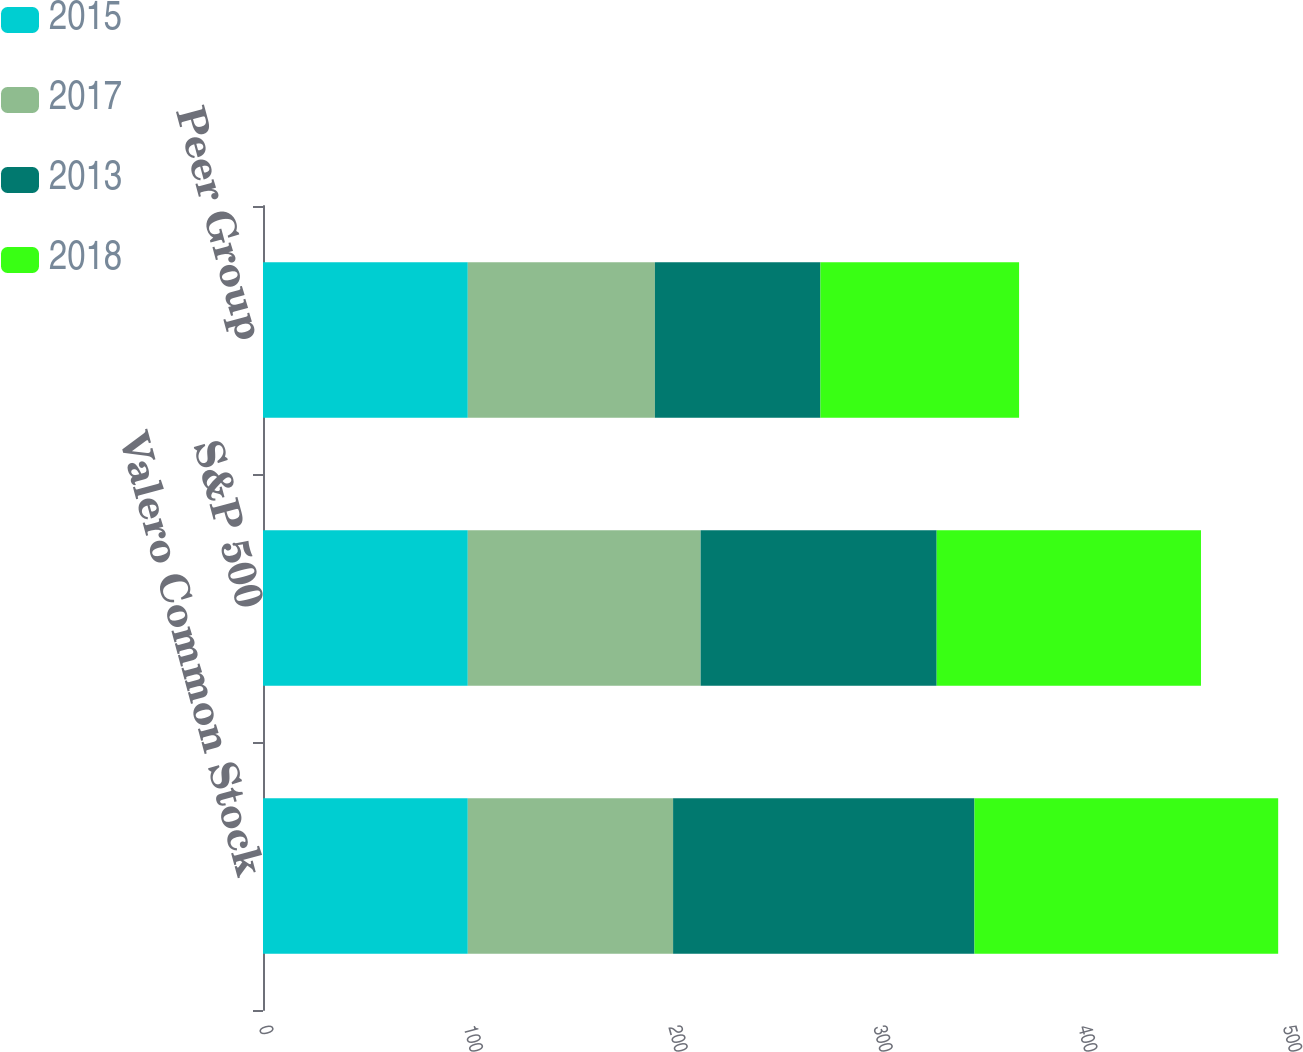Convert chart. <chart><loc_0><loc_0><loc_500><loc_500><stacked_bar_chart><ecel><fcel>Valero Common Stock<fcel>S&P 500<fcel>Peer Group<nl><fcel>2015<fcel>100<fcel>100<fcel>100<nl><fcel>2017<fcel>100.24<fcel>113.69<fcel>91.36<nl><fcel>2013<fcel>147.15<fcel>115.26<fcel>80.82<nl><fcel>2018<fcel>148.3<fcel>129.05<fcel>97<nl></chart> 